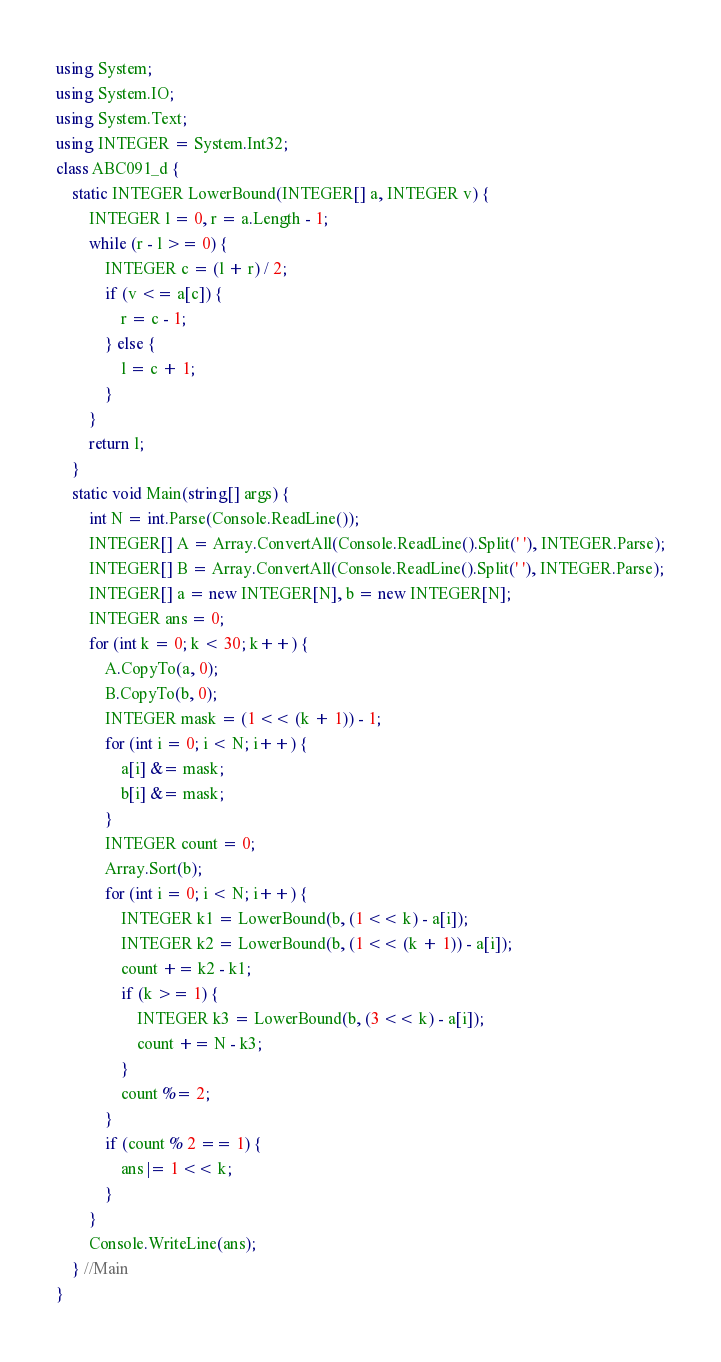Convert code to text. <code><loc_0><loc_0><loc_500><loc_500><_C#_>using System;
using System.IO;
using System.Text;
using INTEGER = System.Int32;
class ABC091_d {
    static INTEGER LowerBound(INTEGER[] a, INTEGER v) {
        INTEGER l = 0, r = a.Length - 1;
        while (r - l >= 0) {
            INTEGER c = (l + r) / 2;
            if (v <= a[c]) {
                r = c - 1;
            } else {
                l = c + 1;
            }
        }
        return l;
    }
    static void Main(string[] args) {
        int N = int.Parse(Console.ReadLine());
        INTEGER[] A = Array.ConvertAll(Console.ReadLine().Split(' '), INTEGER.Parse);
        INTEGER[] B = Array.ConvertAll(Console.ReadLine().Split(' '), INTEGER.Parse);
        INTEGER[] a = new INTEGER[N], b = new INTEGER[N];
        INTEGER ans = 0;
        for (int k = 0; k < 30; k++) {
            A.CopyTo(a, 0);
            B.CopyTo(b, 0);
            INTEGER mask = (1 << (k + 1)) - 1;
            for (int i = 0; i < N; i++) {
                a[i] &= mask;
                b[i] &= mask;
            }
            INTEGER count = 0;
            Array.Sort(b);
            for (int i = 0; i < N; i++) {
                INTEGER k1 = LowerBound(b, (1 << k) - a[i]);
                INTEGER k2 = LowerBound(b, (1 << (k + 1)) - a[i]);
                count += k2 - k1;
                if (k >= 1) {
                    INTEGER k3 = LowerBound(b, (3 << k) - a[i]);
                    count += N - k3;
                }
                count %= 2;
            }
            if (count % 2 == 1) {
                ans |= 1 << k;
            }
        }
        Console.WriteLine(ans);
    } //Main
}
</code> 